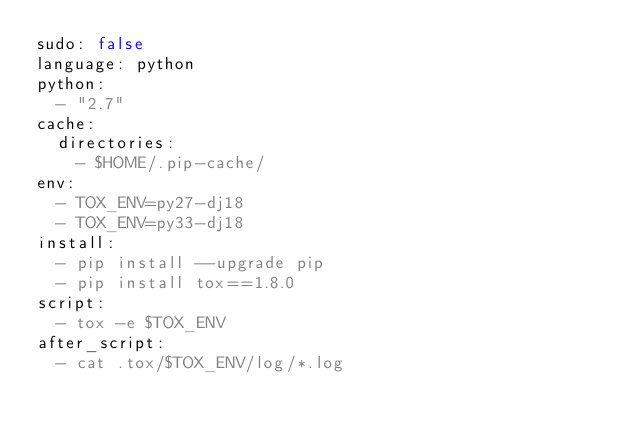<code> <loc_0><loc_0><loc_500><loc_500><_YAML_>sudo: false
language: python
python:
  - "2.7"
cache:
  directories:
    - $HOME/.pip-cache/
env:
  - TOX_ENV=py27-dj18
  - TOX_ENV=py33-dj18
install:
  - pip install --upgrade pip
  - pip install tox==1.8.0
script:
  - tox -e $TOX_ENV
after_script:
  - cat .tox/$TOX_ENV/log/*.log
</code> 